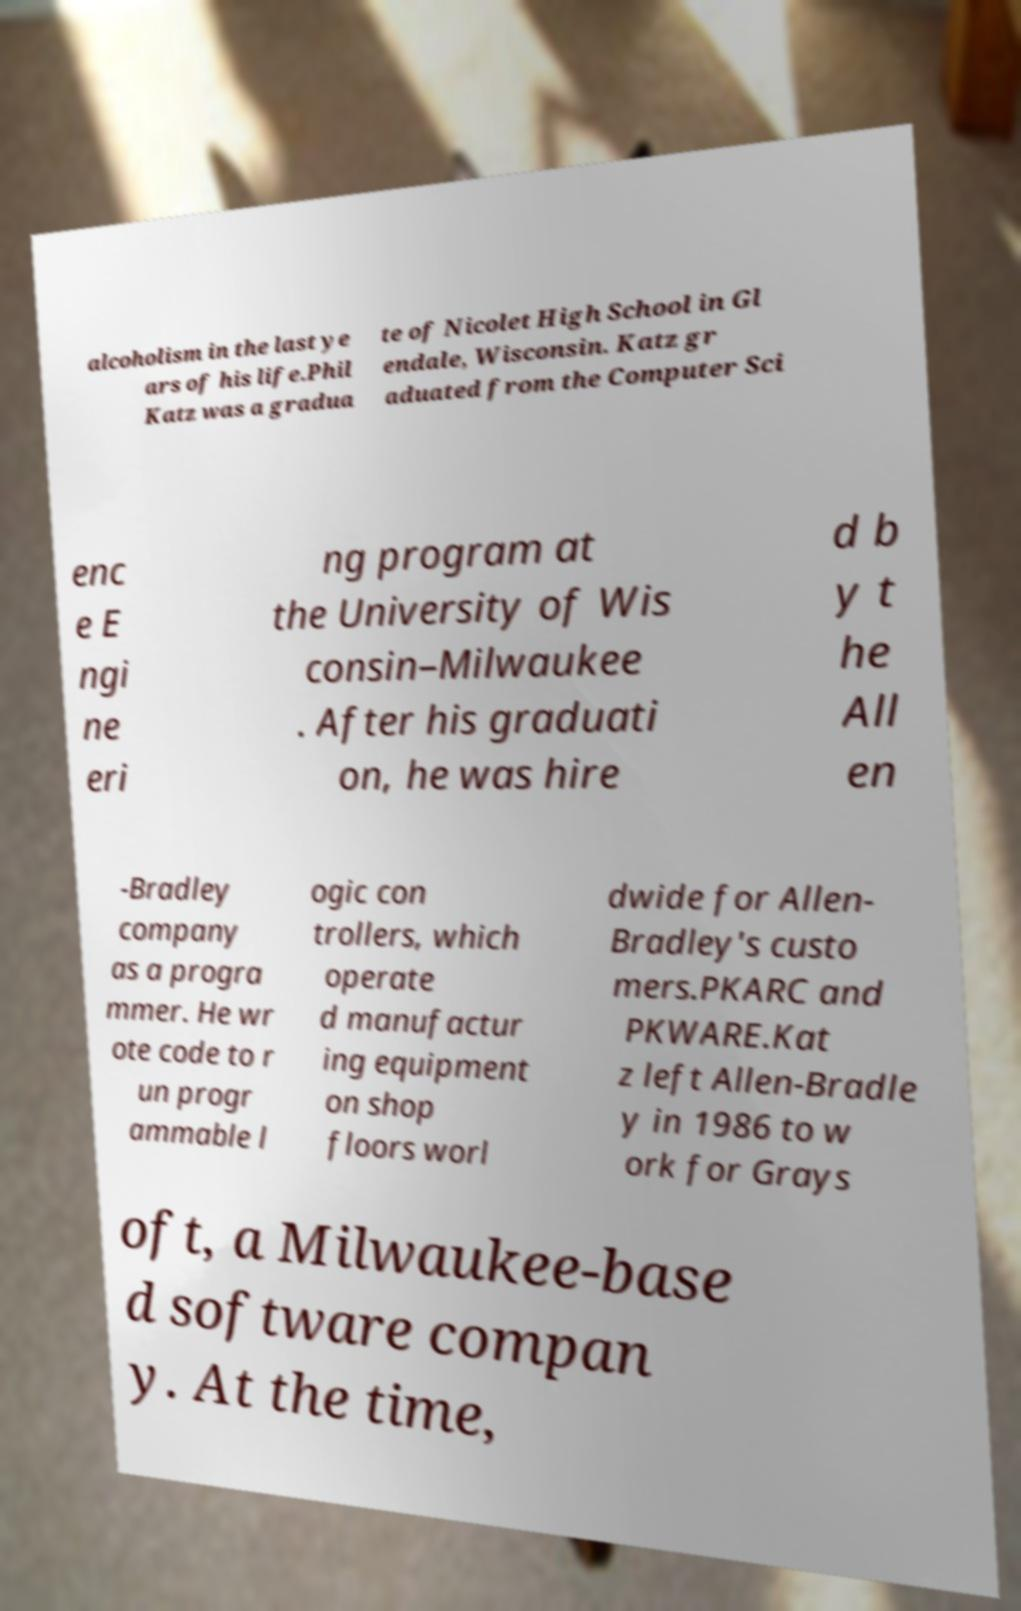Please identify and transcribe the text found in this image. alcoholism in the last ye ars of his life.Phil Katz was a gradua te of Nicolet High School in Gl endale, Wisconsin. Katz gr aduated from the Computer Sci enc e E ngi ne eri ng program at the University of Wis consin–Milwaukee . After his graduati on, he was hire d b y t he All en -Bradley company as a progra mmer. He wr ote code to r un progr ammable l ogic con trollers, which operate d manufactur ing equipment on shop floors worl dwide for Allen- Bradley's custo mers.PKARC and PKWARE.Kat z left Allen-Bradle y in 1986 to w ork for Grays oft, a Milwaukee-base d software compan y. At the time, 